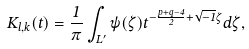Convert formula to latex. <formula><loc_0><loc_0><loc_500><loc_500>K _ { l , k } ( t ) = \frac { 1 } { \pi } \int _ { L ^ { \prime } } \psi ( \zeta ) t ^ { - \frac { p + q - 4 } 2 + \sqrt { - 1 } \zeta } d \zeta ,</formula> 